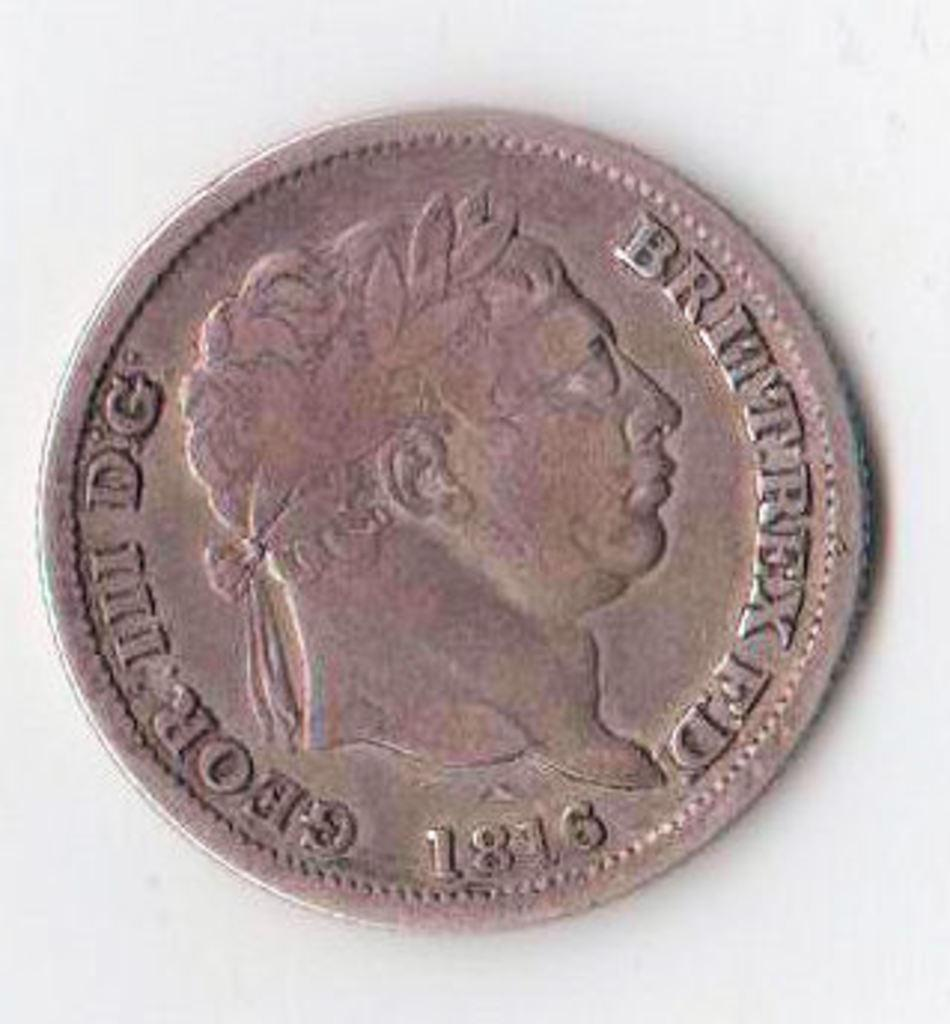Provide a one-sentence caption for the provided image. An old coin reads Brittrex FD 1816 and has a picture of a man on it. 